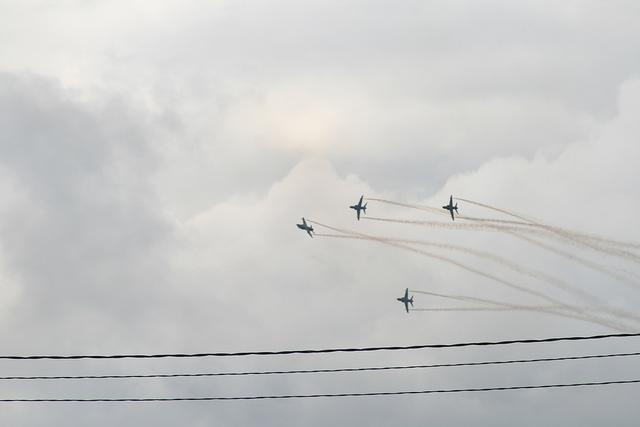How many cows are there?
Give a very brief answer. 0. 